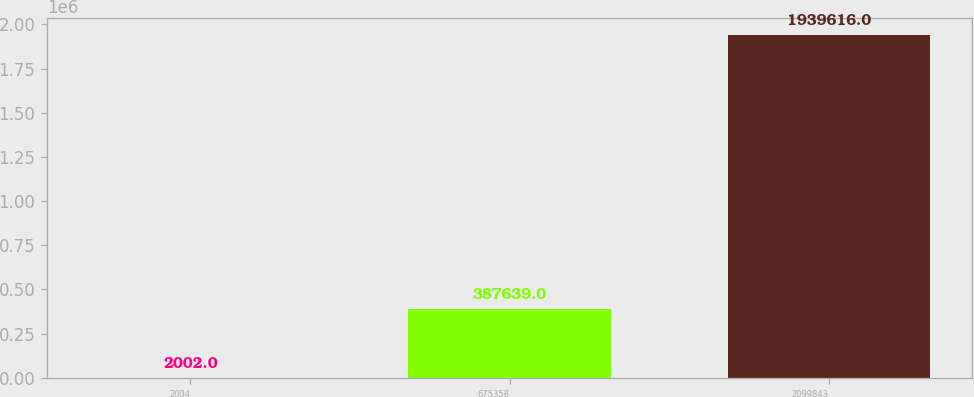Convert chart to OTSL. <chart><loc_0><loc_0><loc_500><loc_500><bar_chart><fcel>2004<fcel>675358<fcel>2099843<nl><fcel>2002<fcel>387639<fcel>1.93962e+06<nl></chart> 